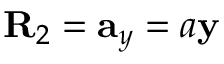<formula> <loc_0><loc_0><loc_500><loc_500>R _ { 2 } = a _ { y } = a y</formula> 